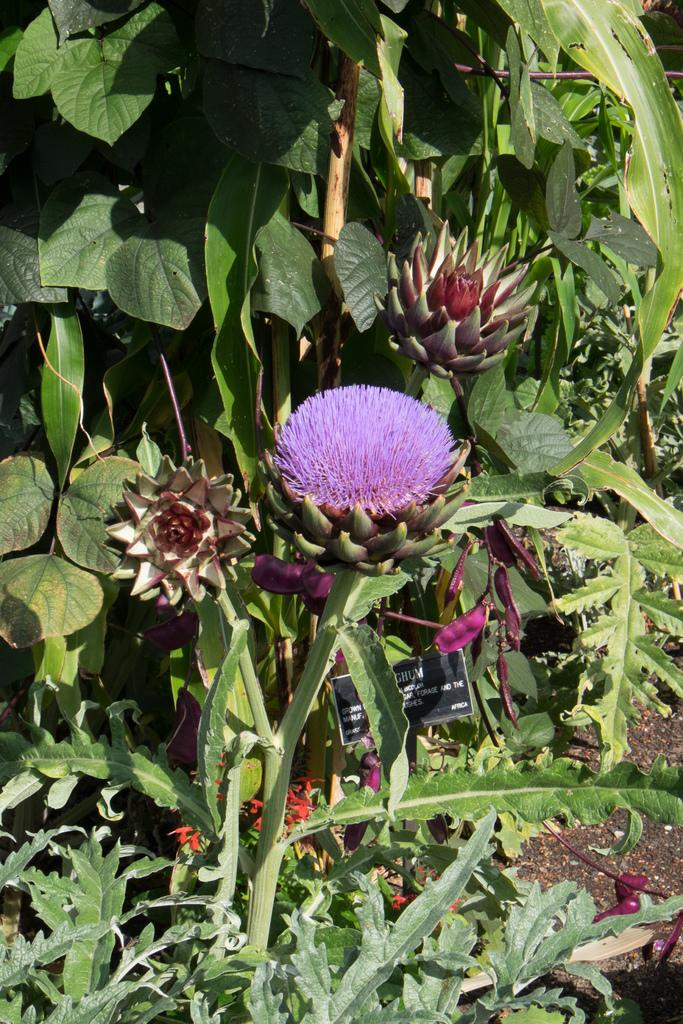What types of flowers can be seen in the image? There are purple flowers and white flowers in the image. What color is the background of the image? The background color is green. What type of society is depicted in the image? There is no society depicted in the image; it features flowers and a green background. How many passengers are visible in the image? There are no passengers present in the image. 